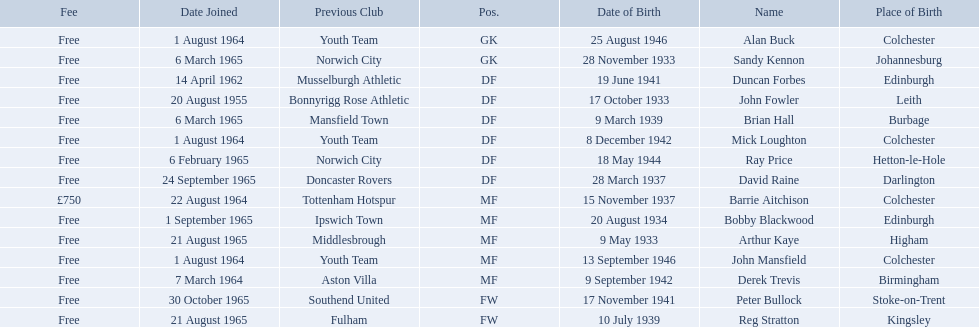Who are all the players? Alan Buck, Sandy Kennon, Duncan Forbes, John Fowler, Brian Hall, Mick Loughton, Ray Price, David Raine, Barrie Aitchison, Bobby Blackwood, Arthur Kaye, John Mansfield, Derek Trevis, Peter Bullock, Reg Stratton. What dates did the players join on? 1 August 1964, 6 March 1965, 14 April 1962, 20 August 1955, 6 March 1965, 1 August 1964, 6 February 1965, 24 September 1965, 22 August 1964, 1 September 1965, 21 August 1965, 1 August 1964, 7 March 1964, 30 October 1965, 21 August 1965. Who is the first player who joined? John Fowler. What is the date of the first person who joined? 20 August 1955. 